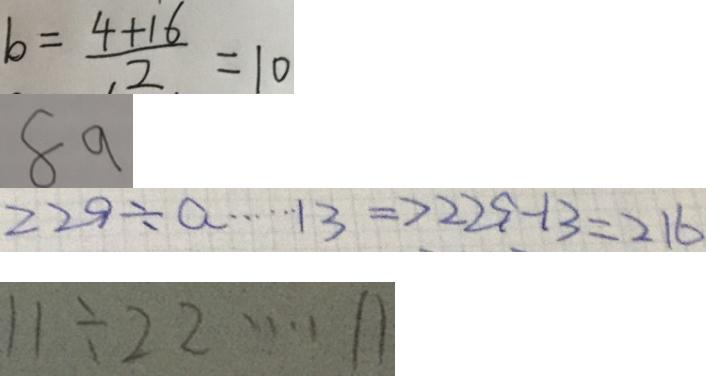Convert formula to latex. <formula><loc_0><loc_0><loc_500><loc_500>b = \frac { 4 + 1 6 } { 2 } = 1 0 
 8 9 
 2 2 9 \div a \cdots 1 3 \Rightarrow 2 2 9 - 1 3 = 2 1 6 
 1 1 \div 2 2 \cdots 1 1</formula> 